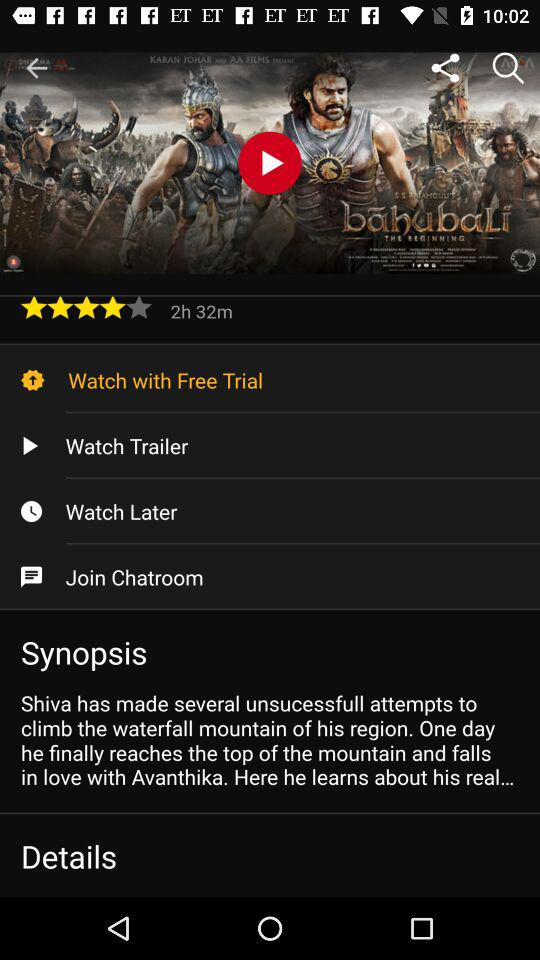What is the movie's name? The movie's name is "bahubaLi THE BEGINNING". 